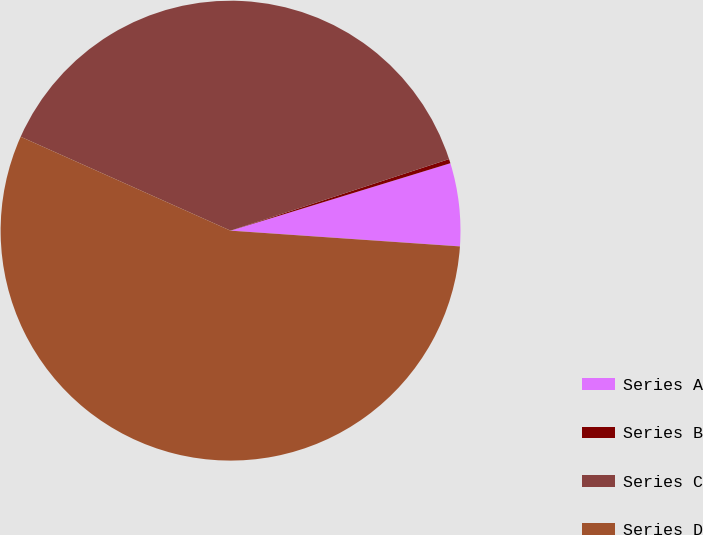Convert chart. <chart><loc_0><loc_0><loc_500><loc_500><pie_chart><fcel>Series A<fcel>Series B<fcel>Series C<fcel>Series D<nl><fcel>5.83%<fcel>0.3%<fcel>38.27%<fcel>55.61%<nl></chart> 